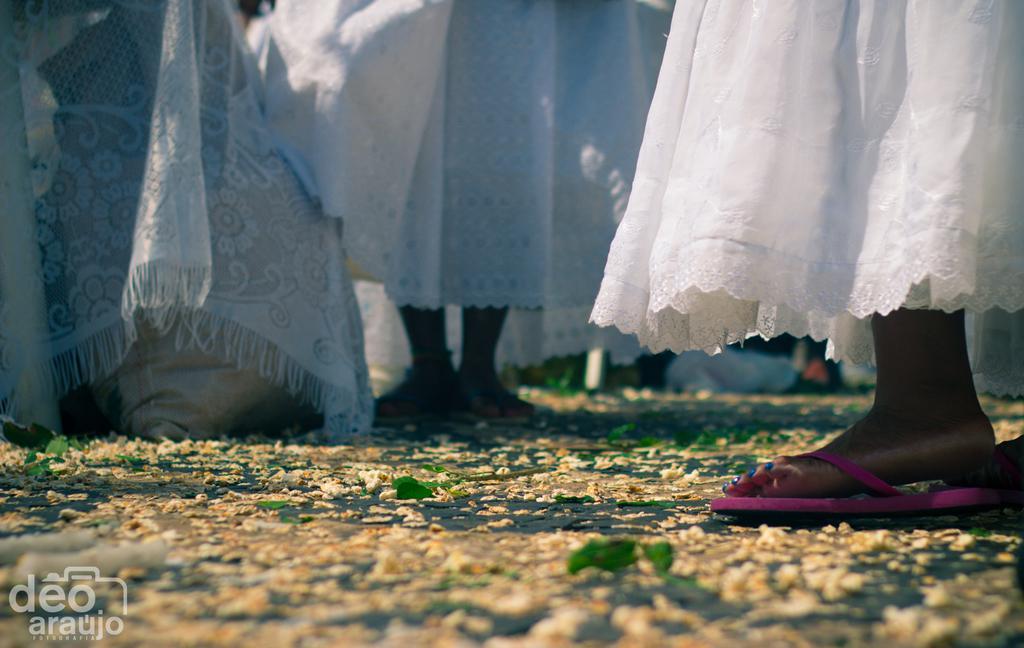How would you summarize this image in a sentence or two? In this picture there are group of people with white dress are standing. At the bottom there are flowers on the road. At the bottom left there is a text. 